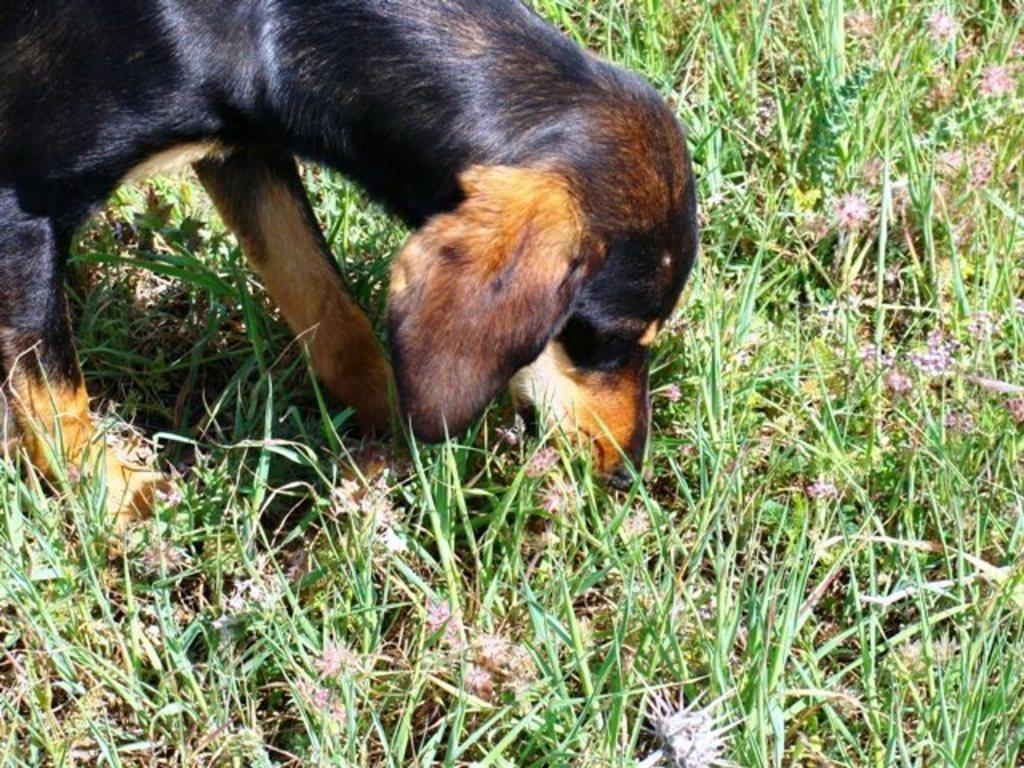What animal can be seen in the image? There is a dog in the image. What is the dog standing on? The dog is standing on the grass ground. Are there any dinosaurs visible in the image? No, there are no dinosaurs present in the image. 